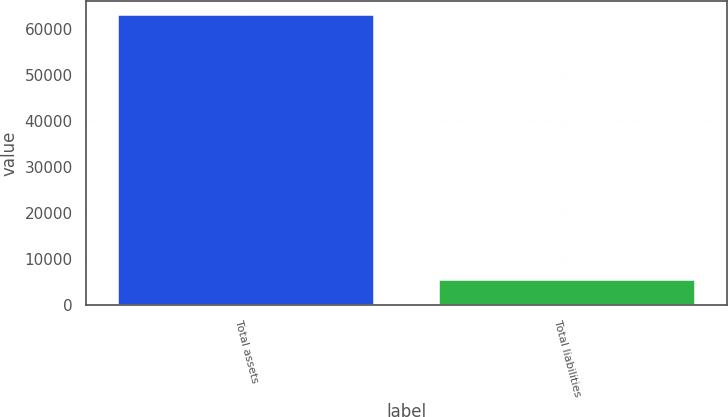Convert chart to OTSL. <chart><loc_0><loc_0><loc_500><loc_500><bar_chart><fcel>Total assets<fcel>Total liabilities<nl><fcel>63096<fcel>5460<nl></chart> 